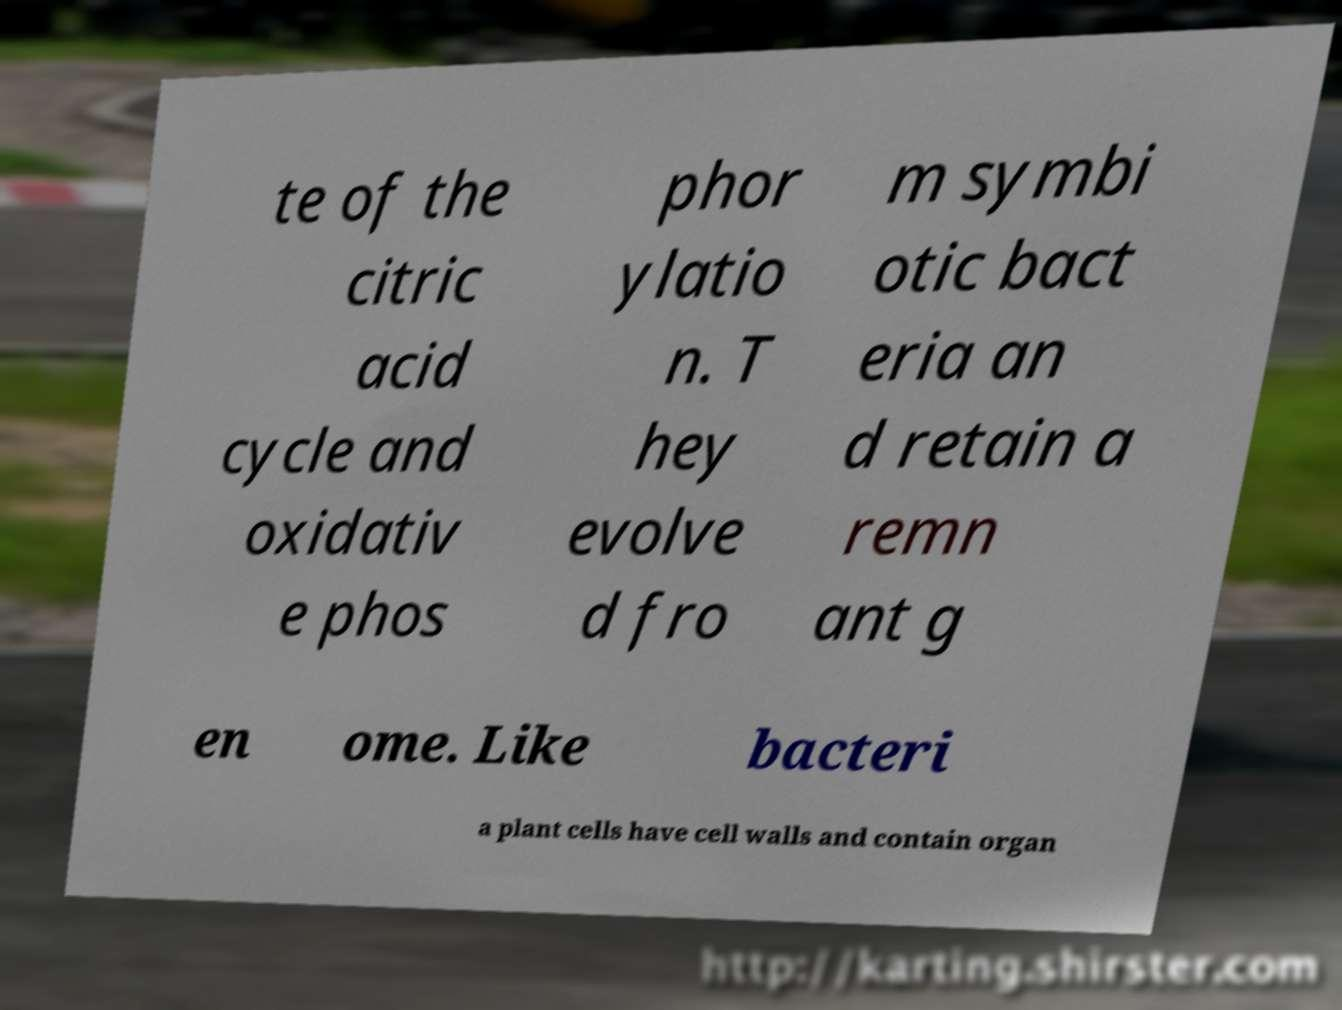Could you extract and type out the text from this image? te of the citric acid cycle and oxidativ e phos phor ylatio n. T hey evolve d fro m symbi otic bact eria an d retain a remn ant g en ome. Like bacteri a plant cells have cell walls and contain organ 